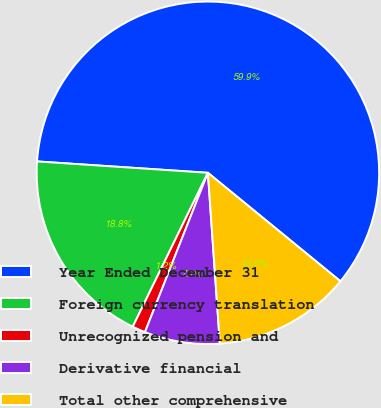<chart> <loc_0><loc_0><loc_500><loc_500><pie_chart><fcel>Year Ended December 31<fcel>Foreign currency translation<fcel>Unrecognized pension and<fcel>Derivative financial<fcel>Total other comprehensive<nl><fcel>59.86%<fcel>18.83%<fcel>1.24%<fcel>7.1%<fcel>12.97%<nl></chart> 